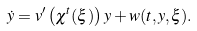<formula> <loc_0><loc_0><loc_500><loc_500>\dot { y } & = v ^ { \prime } \left ( \chi ^ { t } ( \xi ) \right ) y + w ( t , y , \xi ) .</formula> 